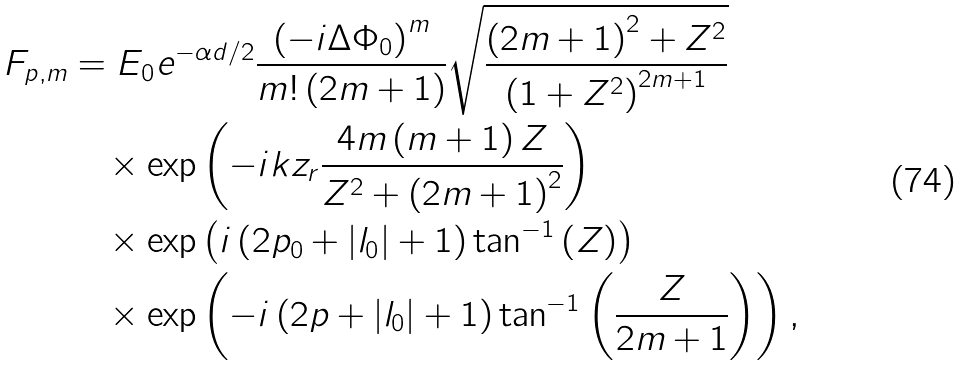<formula> <loc_0><loc_0><loc_500><loc_500>F _ { p , m } & = E _ { 0 } e ^ { - \alpha d / 2 } \frac { \left ( - i \Delta \Phi _ { 0 } \right ) ^ { m } } { m ! \left ( 2 m + 1 \right ) } \sqrt { \frac { \left ( 2 m + 1 \right ) ^ { 2 } + Z ^ { 2 } } { \left ( 1 + Z ^ { 2 } \right ) ^ { 2 m + 1 } } } \\ & \quad \times \exp \left ( - i k z _ { r } \frac { 4 m \left ( m + 1 \right ) Z } { Z ^ { 2 } + \left ( 2 m + 1 \right ) ^ { 2 } } \right ) \\ & \quad \times \exp \left ( i \left ( 2 p _ { 0 } + \left | l _ { 0 } \right | + 1 \right ) \tan ^ { - 1 } \left ( Z \right ) \right ) \\ & \quad \times \exp \left ( - i \left ( 2 p + \left | l _ { 0 } \right | + 1 \right ) \tan ^ { - 1 } \left ( \frac { Z } { 2 m + 1 } \right ) \right ) ,</formula> 